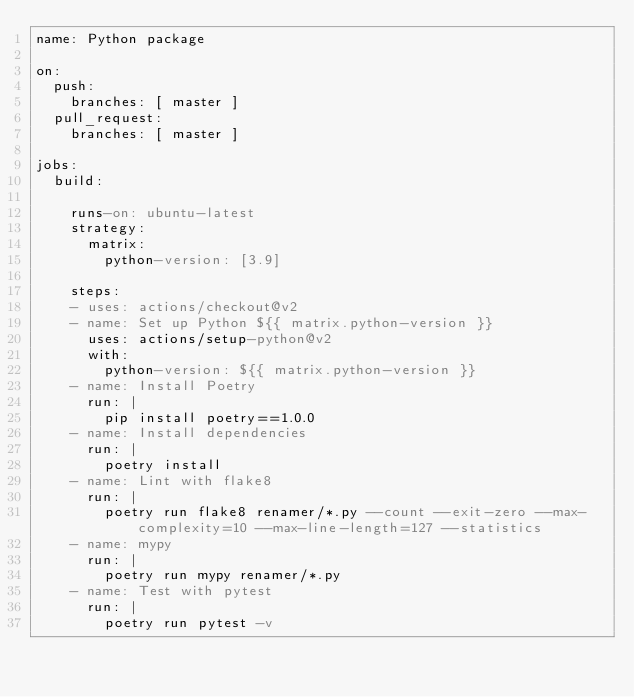<code> <loc_0><loc_0><loc_500><loc_500><_YAML_>name: Python package

on:
  push:
    branches: [ master ]
  pull_request:
    branches: [ master ]

jobs:
  build:

    runs-on: ubuntu-latest
    strategy:
      matrix:
        python-version: [3.9]

    steps:
    - uses: actions/checkout@v2
    - name: Set up Python ${{ matrix.python-version }}
      uses: actions/setup-python@v2
      with:
        python-version: ${{ matrix.python-version }}
    - name: Install Poetry
      run: |
        pip install poetry==1.0.0
    - name: Install dependencies
      run: |
        poetry install
    - name: Lint with flake8
      run: |
        poetry run flake8 renamer/*.py --count --exit-zero --max-complexity=10 --max-line-length=127 --statistics
    - name: mypy
      run: |
        poetry run mypy renamer/*.py
    - name: Test with pytest
      run: |
        poetry run pytest -v
</code> 